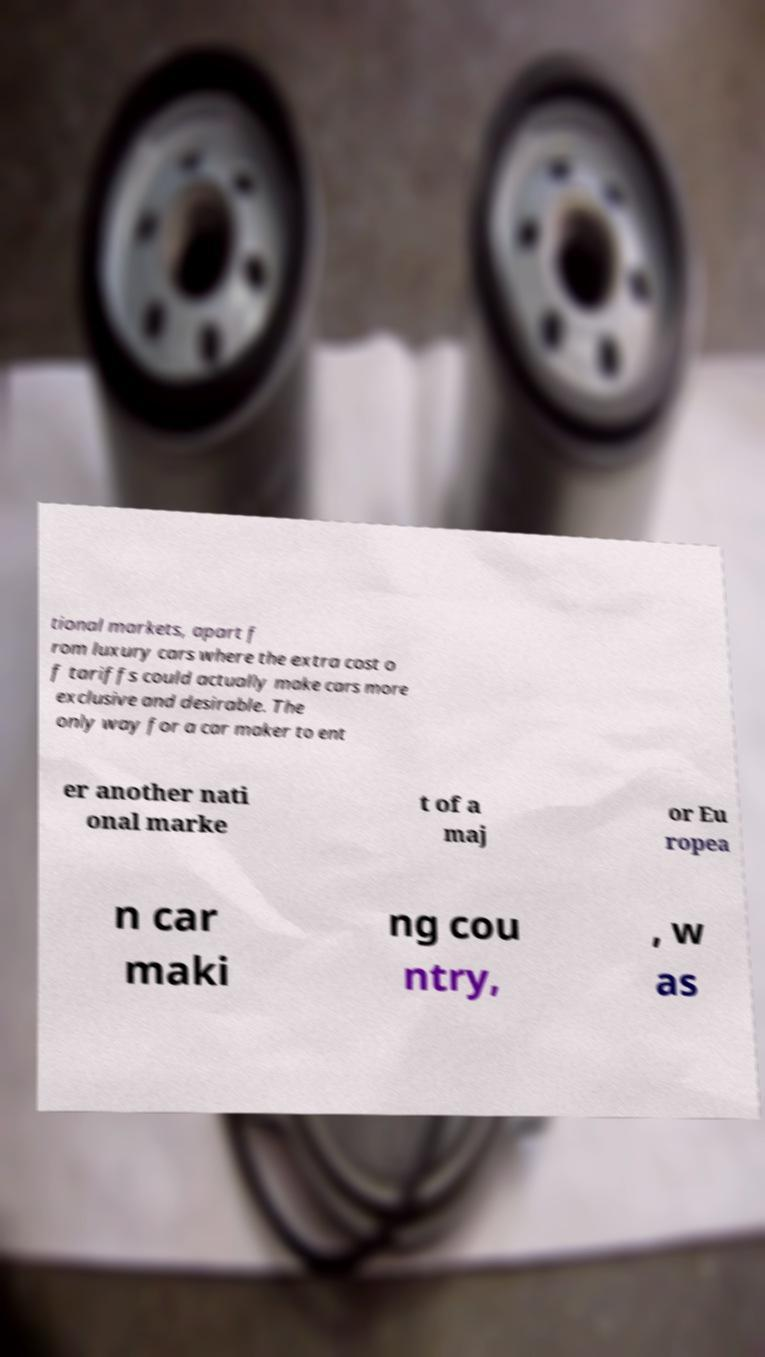For documentation purposes, I need the text within this image transcribed. Could you provide that? tional markets, apart f rom luxury cars where the extra cost o f tariffs could actually make cars more exclusive and desirable. The only way for a car maker to ent er another nati onal marke t of a maj or Eu ropea n car maki ng cou ntry, , w as 